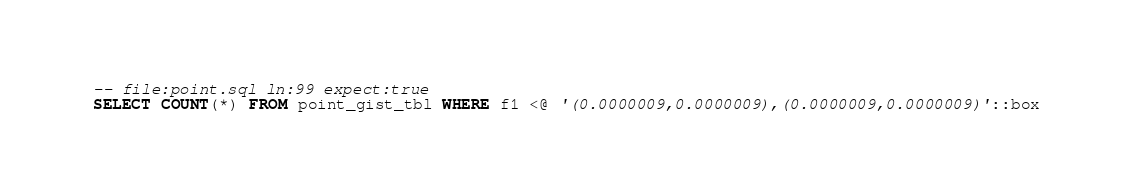<code> <loc_0><loc_0><loc_500><loc_500><_SQL_>-- file:point.sql ln:99 expect:true
SELECT COUNT(*) FROM point_gist_tbl WHERE f1 <@ '(0.0000009,0.0000009),(0.0000009,0.0000009)'::box
</code> 